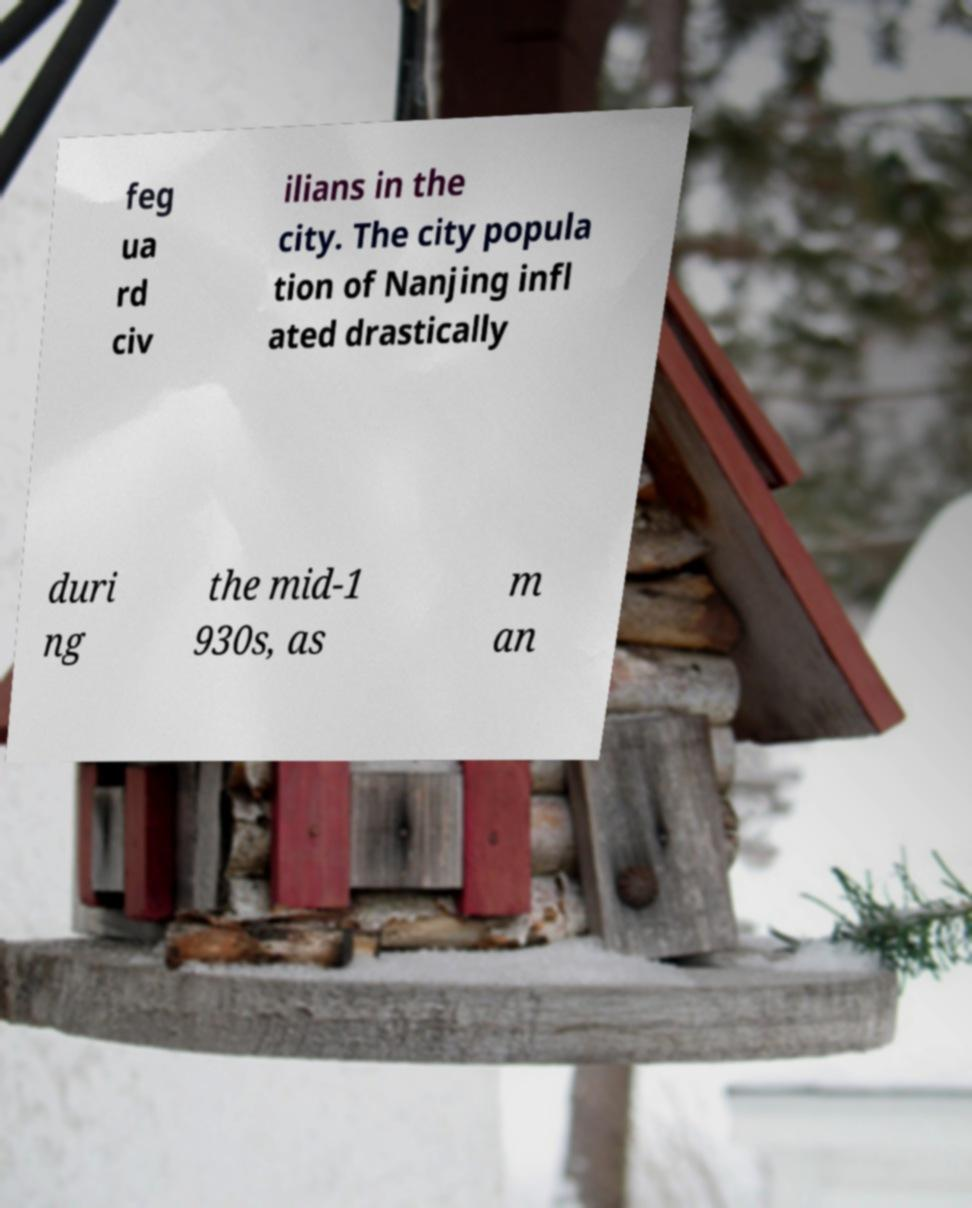Can you accurately transcribe the text from the provided image for me? feg ua rd civ ilians in the city. The city popula tion of Nanjing infl ated drastically duri ng the mid-1 930s, as m an 